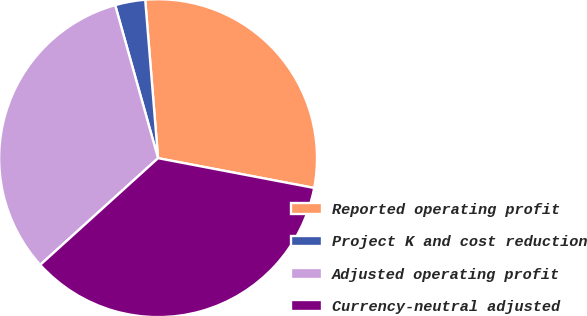<chart> <loc_0><loc_0><loc_500><loc_500><pie_chart><fcel>Reported operating profit<fcel>Project K and cost reduction<fcel>Adjusted operating profit<fcel>Currency-neutral adjusted<nl><fcel>29.29%<fcel>3.06%<fcel>32.36%<fcel>35.29%<nl></chart> 